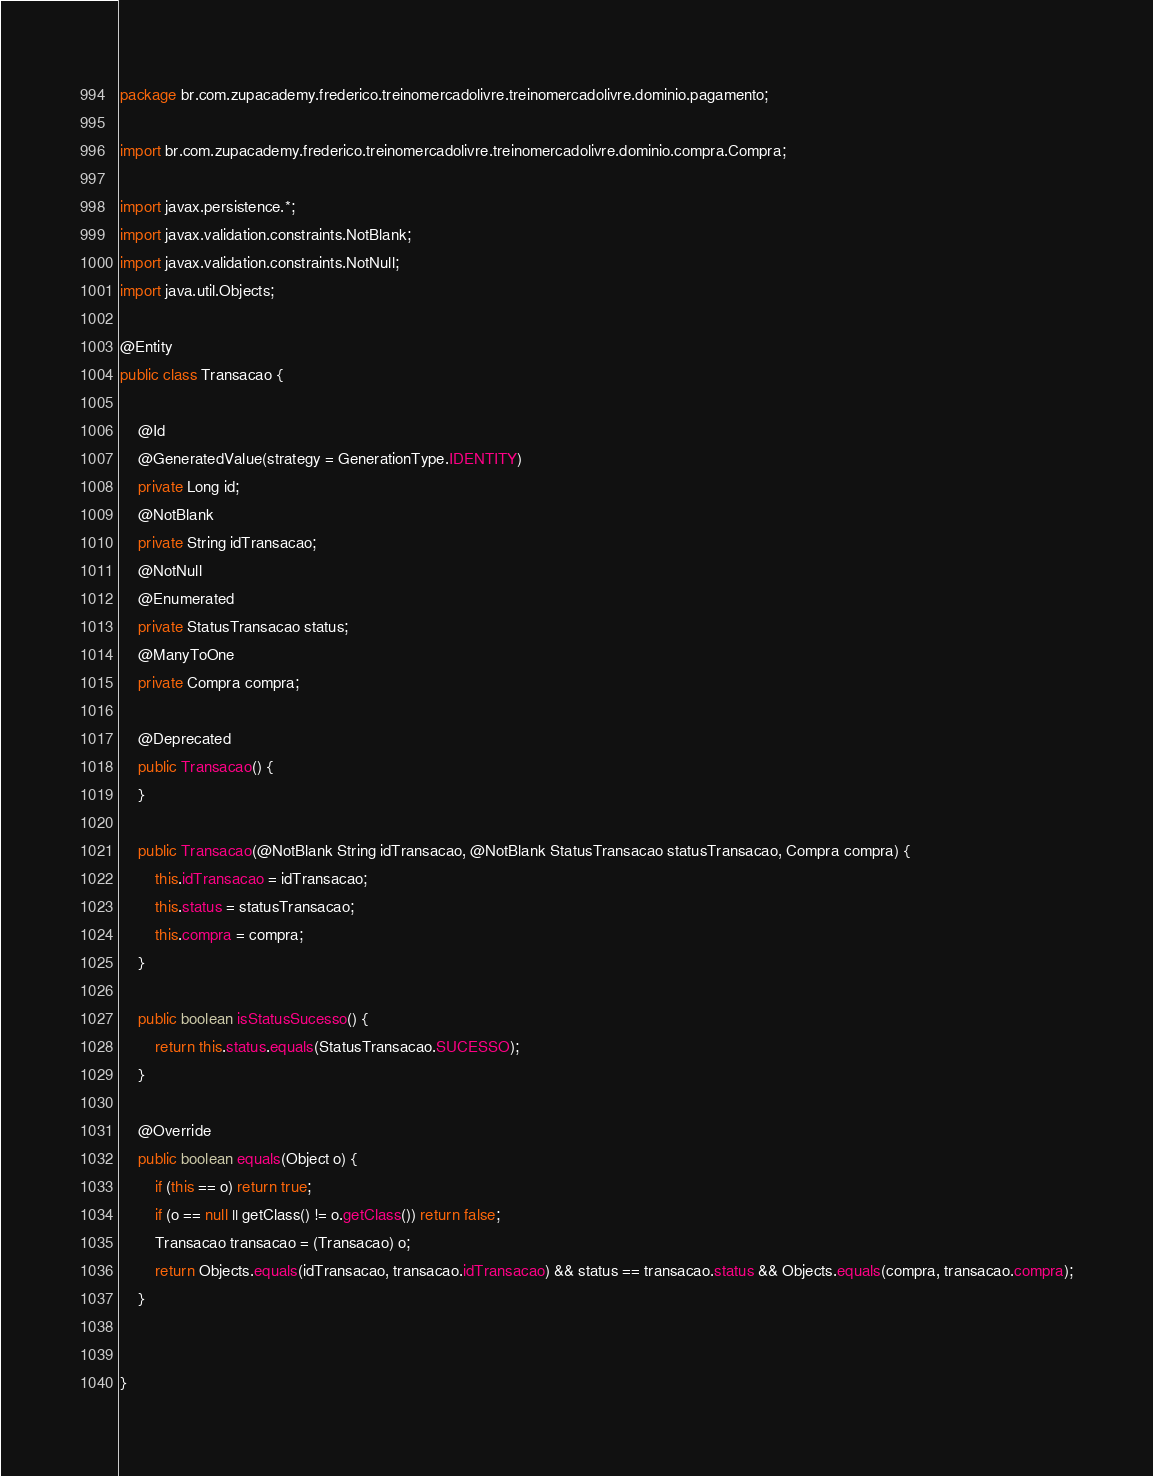<code> <loc_0><loc_0><loc_500><loc_500><_Java_>package br.com.zupacademy.frederico.treinomercadolivre.treinomercadolivre.dominio.pagamento;

import br.com.zupacademy.frederico.treinomercadolivre.treinomercadolivre.dominio.compra.Compra;

import javax.persistence.*;
import javax.validation.constraints.NotBlank;
import javax.validation.constraints.NotNull;
import java.util.Objects;

@Entity
public class Transacao {

    @Id
    @GeneratedValue(strategy = GenerationType.IDENTITY)
    private Long id;
    @NotBlank
    private String idTransacao;
    @NotNull
    @Enumerated
    private StatusTransacao status;
    @ManyToOne
    private Compra compra;

    @Deprecated
    public Transacao() {
    }

    public Transacao(@NotBlank String idTransacao, @NotBlank StatusTransacao statusTransacao, Compra compra) {
        this.idTransacao = idTransacao;
        this.status = statusTransacao;
        this.compra = compra;
    }

    public boolean isStatusSucesso() {
        return this.status.equals(StatusTransacao.SUCESSO);
    }

    @Override
    public boolean equals(Object o) {
        if (this == o) return true;
        if (o == null || getClass() != o.getClass()) return false;
        Transacao transacao = (Transacao) o;
        return Objects.equals(idTransacao, transacao.idTransacao) && status == transacao.status && Objects.equals(compra, transacao.compra);
    }


}
</code> 